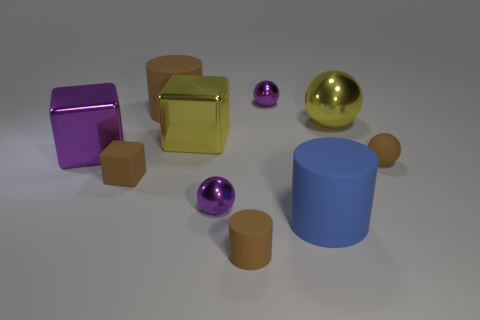Are there fewer shiny cubes right of the large blue rubber cylinder than tiny brown balls?
Offer a very short reply. Yes. Is the big purple thing the same shape as the big blue thing?
Provide a succinct answer. No. There is a matte thing in front of the big rubber cylinder that is on the right side of the small purple shiny sphere in front of the small block; what size is it?
Offer a very short reply. Small. There is a small object that is the same shape as the big blue object; what is its material?
Keep it short and to the point. Rubber. Are there any other things that have the same size as the purple block?
Offer a terse response. Yes. There is a brown matte cylinder right of the matte cylinder that is on the left side of the big yellow metallic cube; how big is it?
Make the answer very short. Small. The matte sphere has what color?
Ensure brevity in your answer.  Brown. What number of purple metal objects are behind the brown matte object that is on the right side of the large blue cylinder?
Provide a succinct answer. 2. Is there a small sphere that is on the right side of the cube that is on the right side of the big brown rubber cylinder?
Provide a short and direct response. Yes. There is a blue matte cylinder; are there any large blue objects on the right side of it?
Give a very brief answer. No. 